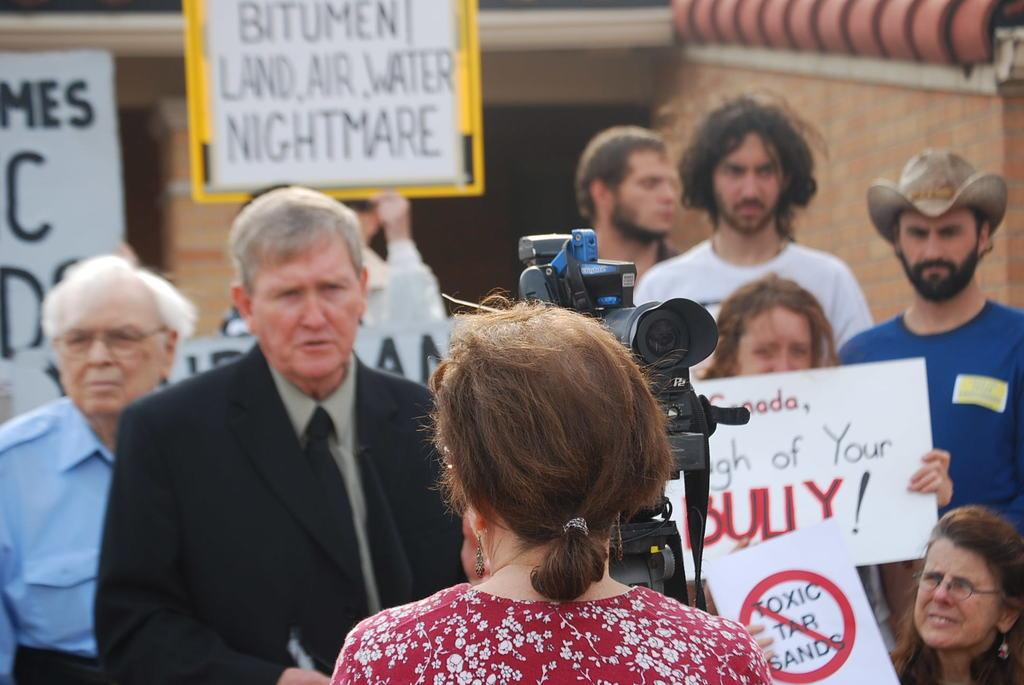What is the woman at the bottom of the image doing? The woman is standing at the bottom of the image and holding a camera. What are the people behind the woman holding? The people behind the woman are holding banners. What can be seen in the background of the image? There is a building in the background of the image. Where is the nest located in the image? There is no nest present in the image. What type of kite is being flown by the woman in the image? The woman is not flying a kite in the image; she is holding a camera. 